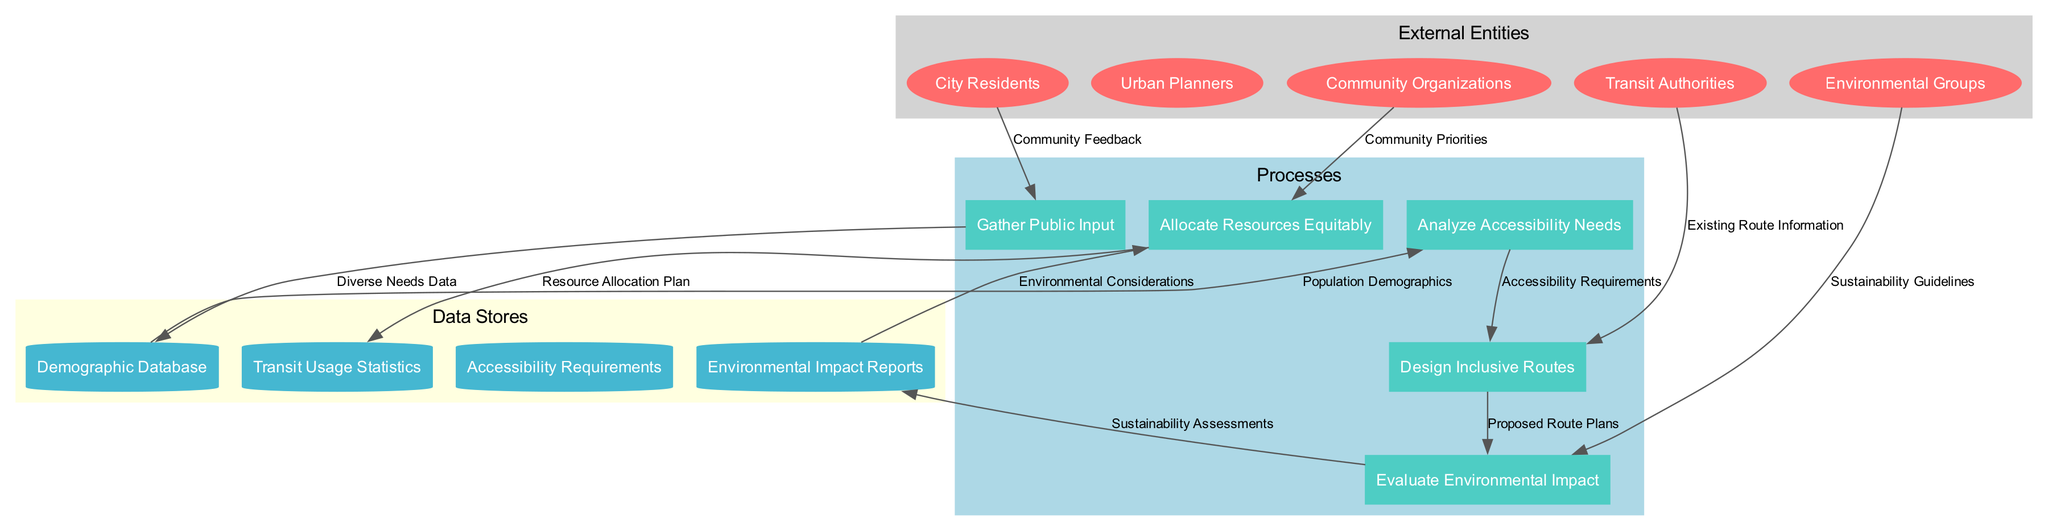What are the external entities represented in the diagram? The external entities listed in the diagram are City Residents, Urban Planners, Transit Authorities, Community Organizations, and Environmental Groups. They are displayed as ellipses within the external entities cluster.
Answer: City Residents, Urban Planners, Transit Authorities, Community Organizations, Environmental Groups How many processes are shown in the diagram? There are five processes identified in the diagram: Gather Public Input, Analyze Accessibility Needs, Design Inclusive Routes, Evaluate Environmental Impact, and Allocate Resources Equitably. These are represented in the processes cluster.
Answer: 5 Which process receives data from the Demographic Database? The process Analyze Accessibility Needs receives data labeled Population Demographics from the Demographic Database, as indicated by the directed edge in the diagram.
Answer: Analyze Accessibility Needs What type of data flows from Community Organizations to Allocate Resources Equitably? The data flow from Community Organizations to Allocate Resources Equitably is labeled Community Priorities, showing the type of data that informs the resource allocation process.
Answer: Community Priorities What data does Environmental Groups provide to Evaluate Environmental Impact? Environmental Groups provide data labeled Sustainability Guidelines to the process Evaluate Environmental Impact, indicating their role in sustainability considerations.
Answer: Sustainability Guidelines Which data store receives the output from Evaluate Environmental Impact? The Environmental Impact Reports data store receives outputs from the Evaluate Environmental Impact process, represented by the directed data flow in the diagram.
Answer: Environmental Impact Reports How does the data flow from Gather Public Input to Demographic Database facilitate planning? The flow allows diverse community feedback collected in Gather Public Input to be stored in the Demographic Database as Diverse Needs Data, which is essential for understanding the population's needs for effective planning.
Answer: Diverse Needs Data What is the final output of the Allocate Resources Equitably process? The final output of the Allocate Resources Equitably process is the Resource Allocation Plan, as shown by the directed flow towards the Transit Usage Statistics data store.
Answer: Resource Allocation Plan 